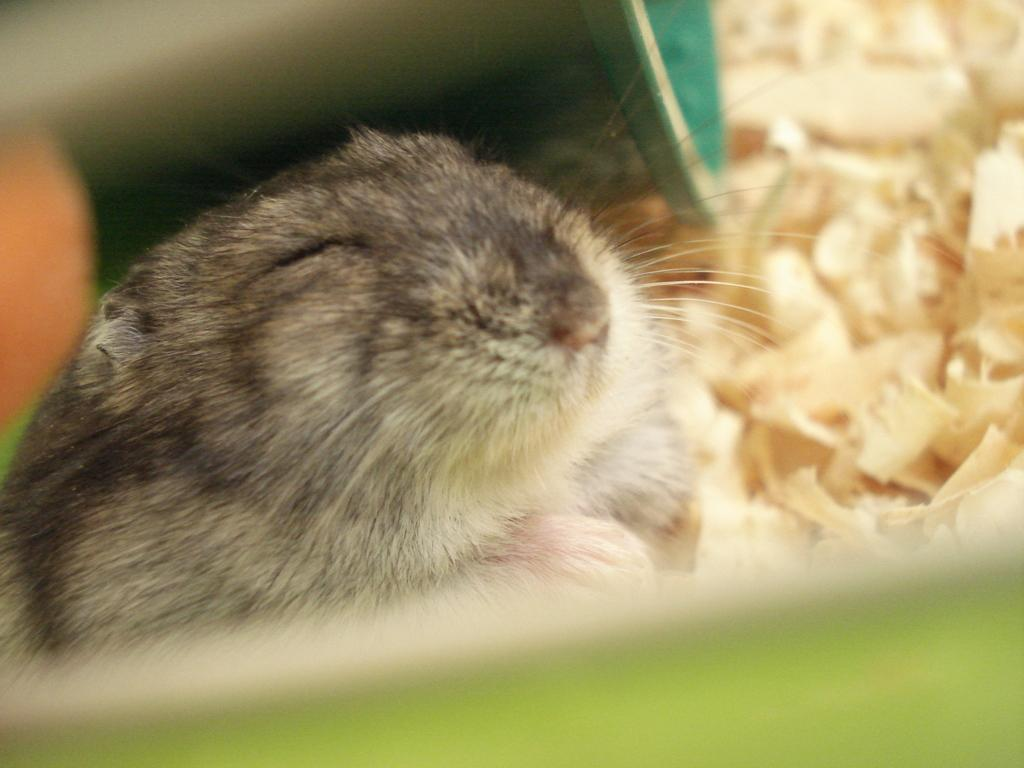What type of animal can be seen in the image? There is a rat in the image. What else can be seen in the image besides the rat? There are other objects in the image. Reasoning: Let' Let's think step by step in order to produce the conversation. We start by identifying the main subject in the image, which is the rat. Then, we acknowledge the presence of other objects in the image, without specifying what they are, as we only have one fact about them. Each question is designed to elicit a specific detail about the image that is known from the provided facts. Absurd Question/Answer: What type of minute is visible in the image? There is no mention of a minute in the image, as the facts only mention a rat and other objects. What type of underwear is visible in the image? There is no mention of underwear in the image, as the facts only mention a rat and other objects. --- Facts: 1. There is a person sitting on a chair in the image. 2. The person is holding a book. 3. There is a table next to the chair. 4. The table has a lamp on it. Absurd Topics: elephant, ocean, bicycle Conversation: What is the person in the image doing? The person is sitting on a chair in the image. What is the person holding in the image? The person is holding a book in the image. What is next to the chair in the image? There is a table next to the chair in the image. What is on the table in the image? The table has a lamp on it in the image. Reasoning: Let's think step by step in order to produce the conversation. We start by identifying the main subject in the image, which is the person sitting on a chair. Then, we describe what the person is doing, which is holding a book. Next, we mention the presence of a table next to the chair. Finally, we describe what is on the table, which is a lamp. Each question is designed to elicit 